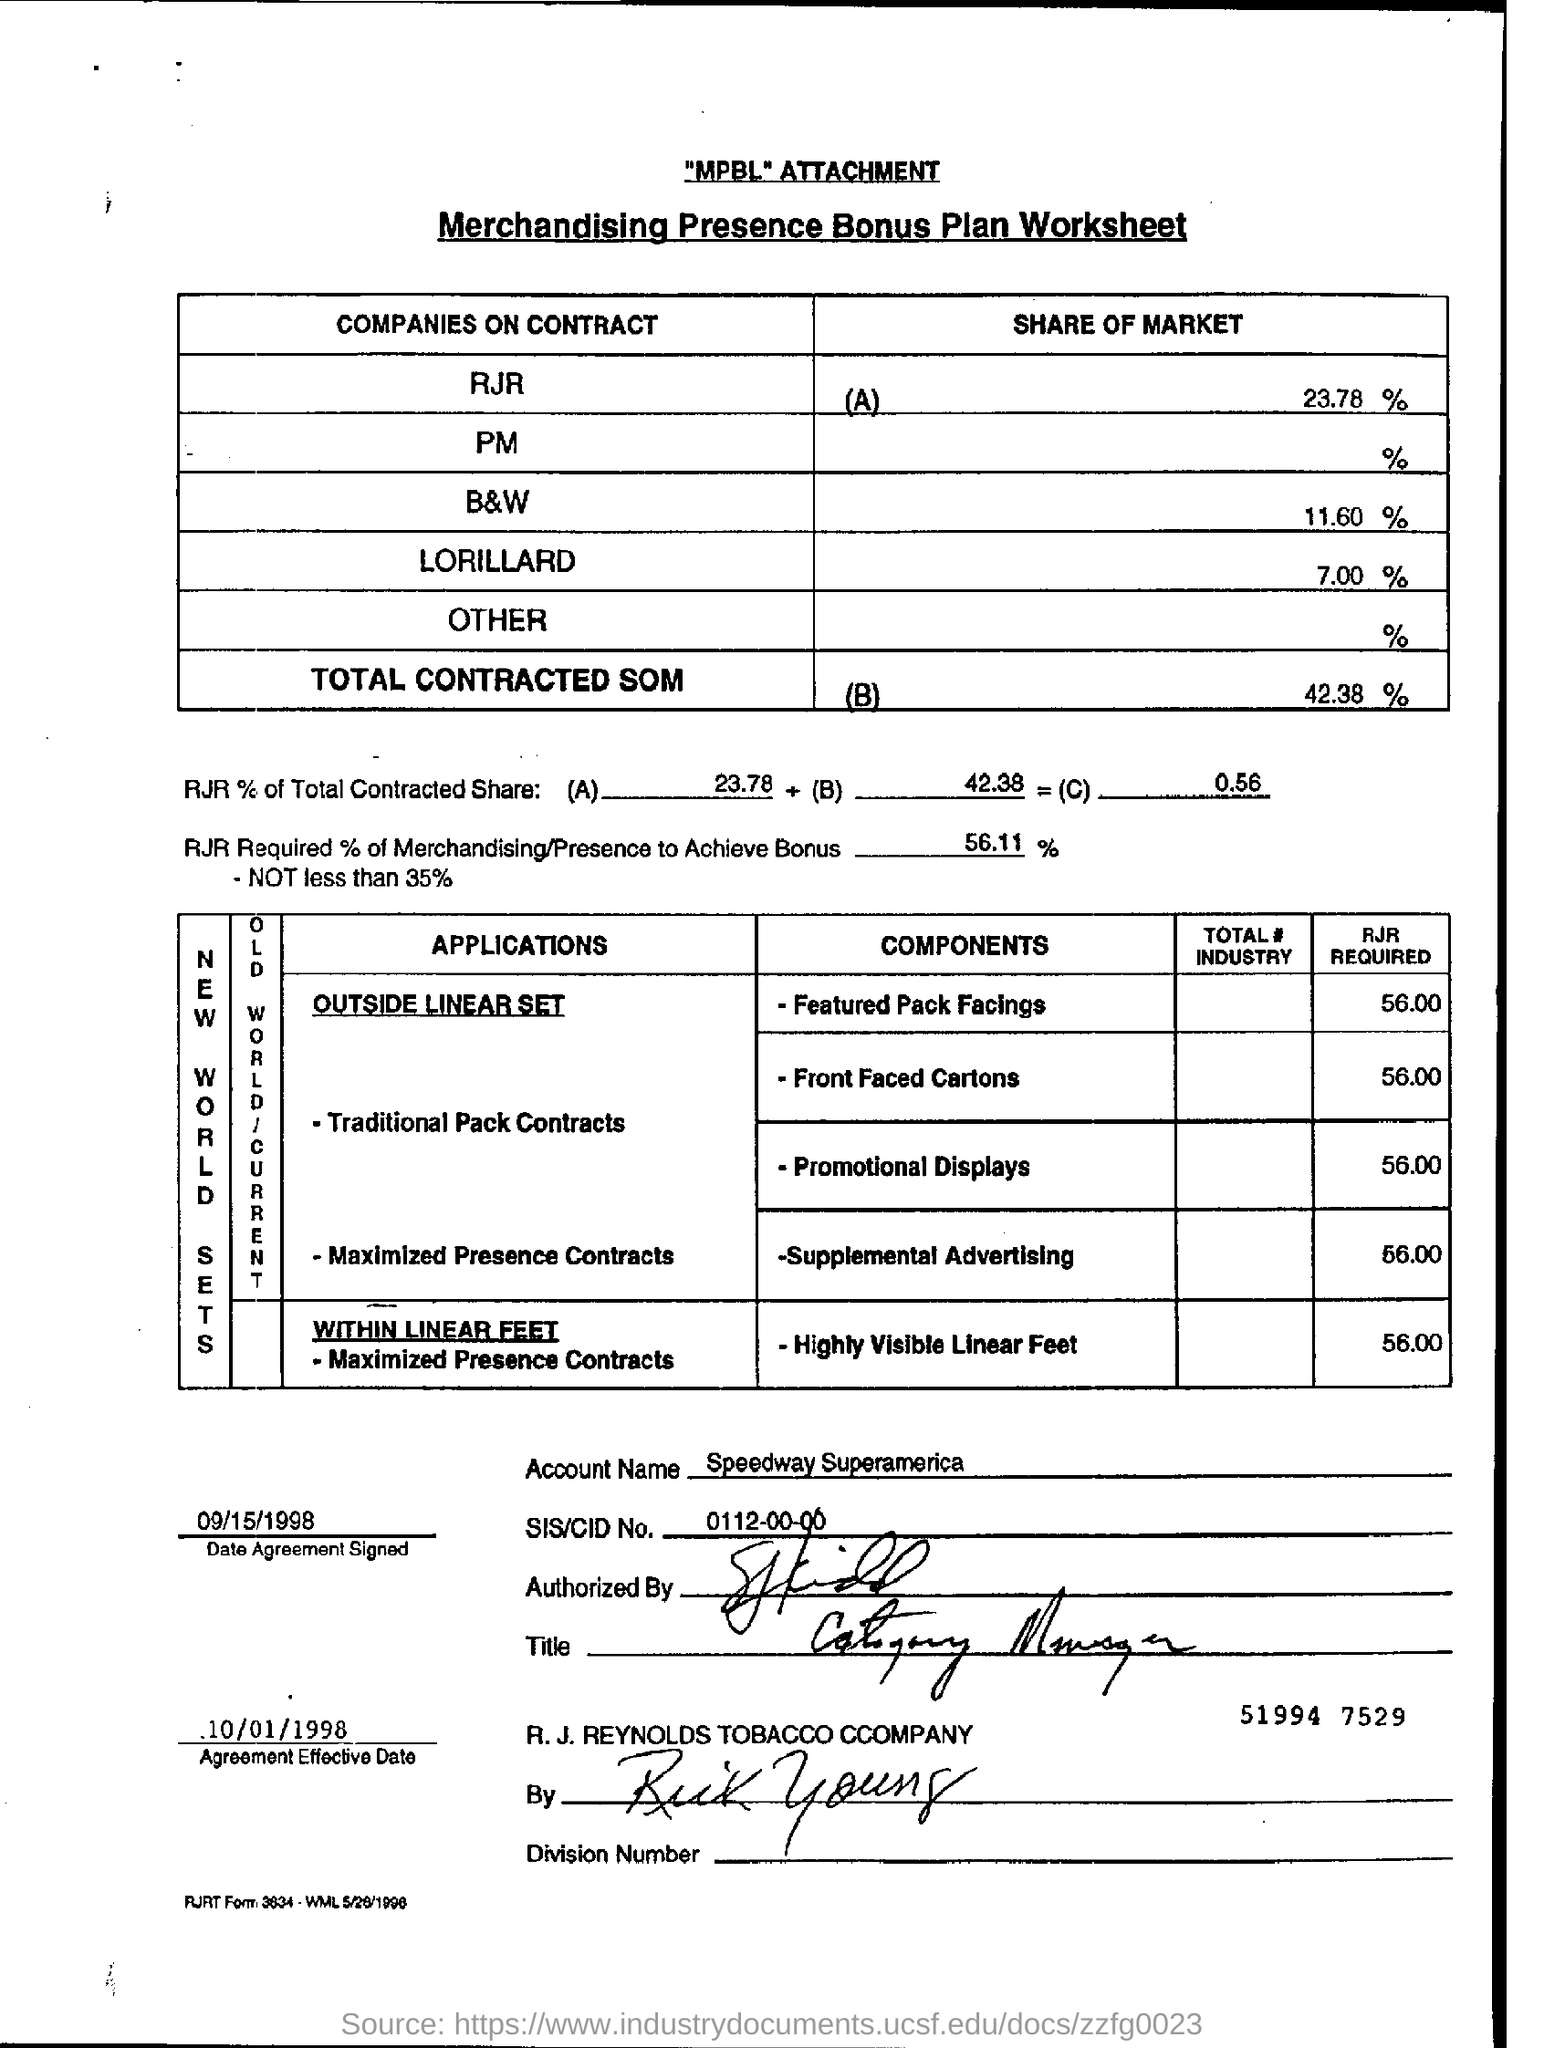What is the SHARE OF MARKET of COMPANIES ON CONTRACT -B&W?
Offer a very short reply. 11.60%. What is the RJR REQUIRED for Supplemental Advertising?
Give a very brief answer. 56.00. What is the Account Name mentioned?
Keep it short and to the point. Speedway Superamerica. What is the SIS/CID No mentioned?
Your answer should be compact. 0112-00-00. 